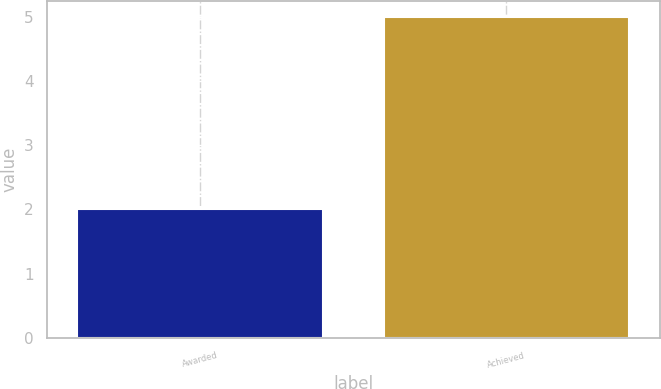Convert chart. <chart><loc_0><loc_0><loc_500><loc_500><bar_chart><fcel>Awarded<fcel>Achieved<nl><fcel>2<fcel>5<nl></chart> 